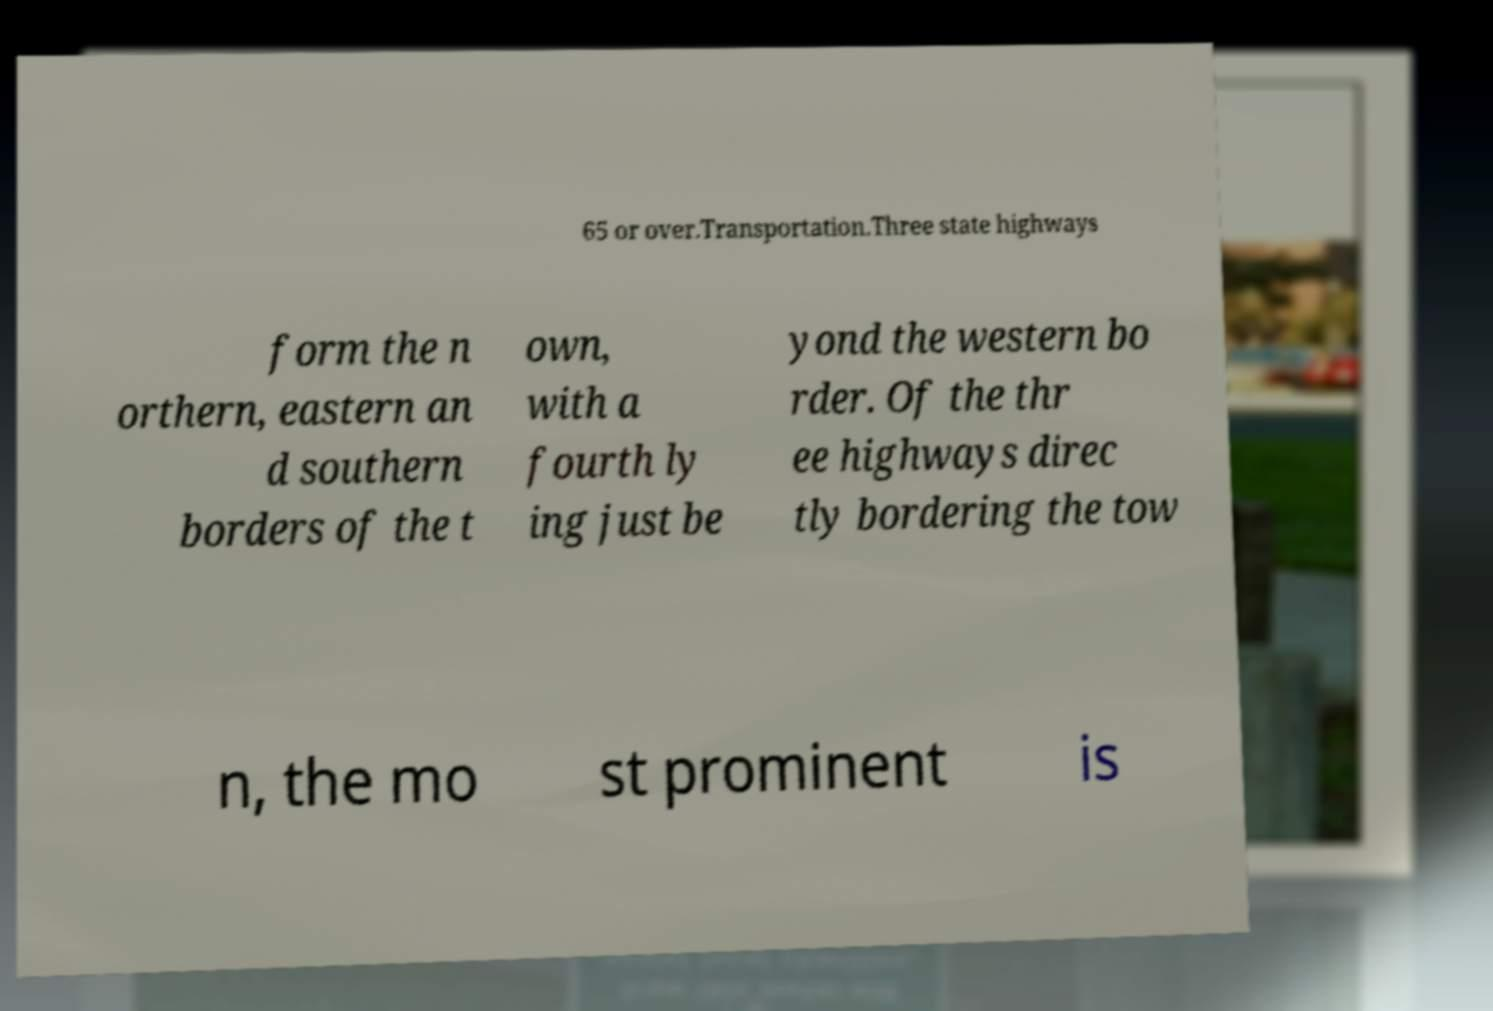Can you read and provide the text displayed in the image?This photo seems to have some interesting text. Can you extract and type it out for me? 65 or over.Transportation.Three state highways form the n orthern, eastern an d southern borders of the t own, with a fourth ly ing just be yond the western bo rder. Of the thr ee highways direc tly bordering the tow n, the mo st prominent is 